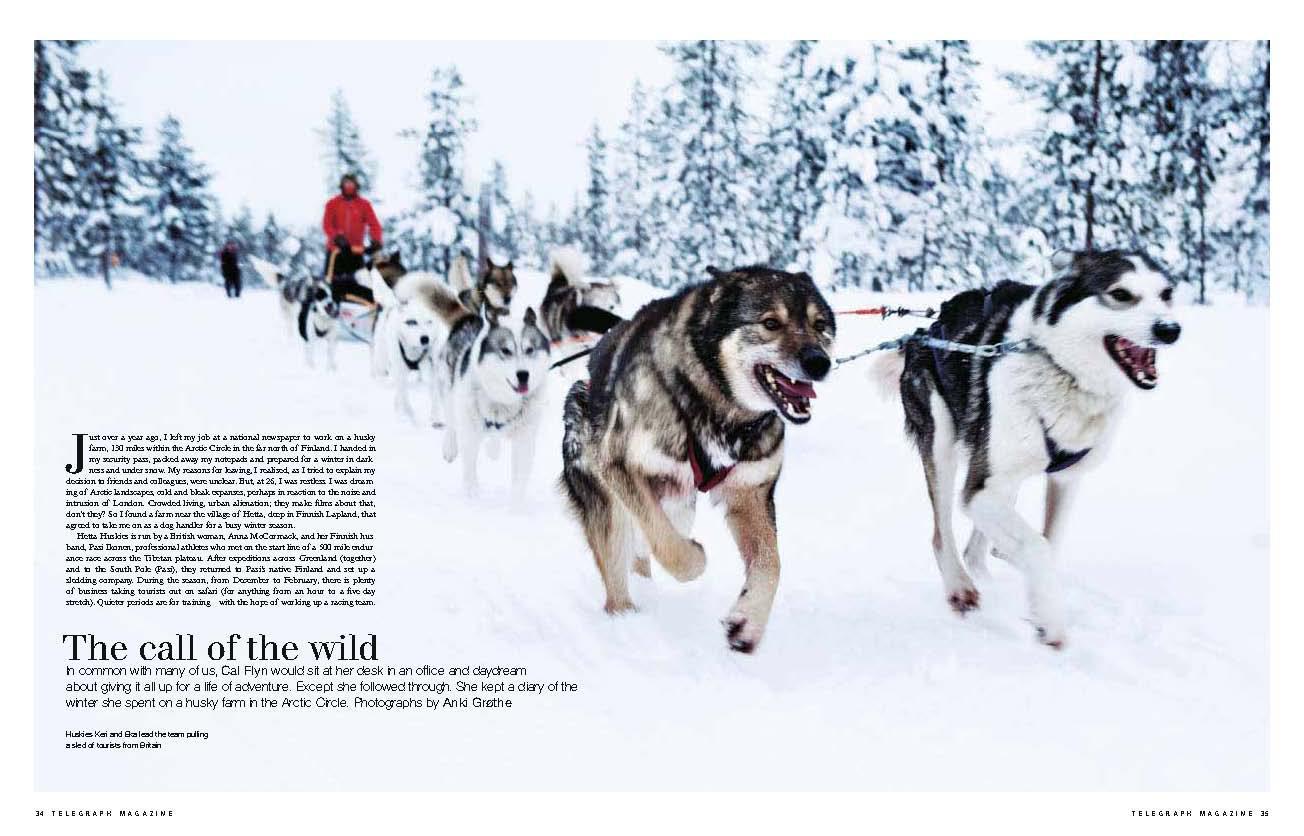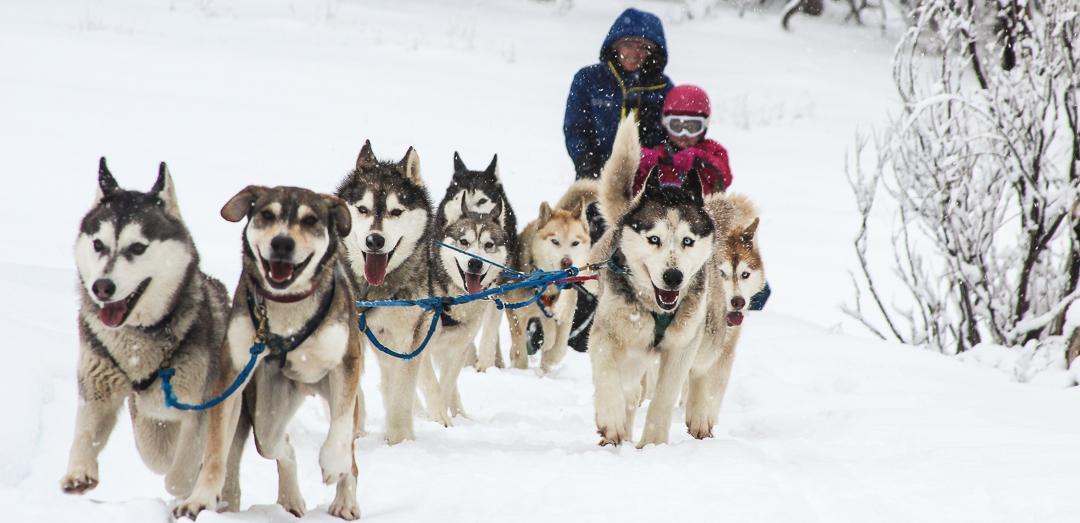The first image is the image on the left, the second image is the image on the right. For the images shown, is this caption "One of the images features two people riding a single sled." true? Answer yes or no. Yes. The first image is the image on the left, the second image is the image on the right. Given the left and right images, does the statement "The dog sled teams in the left and right images are moving forward and are angled so they head toward each other." hold true? Answer yes or no. Yes. 